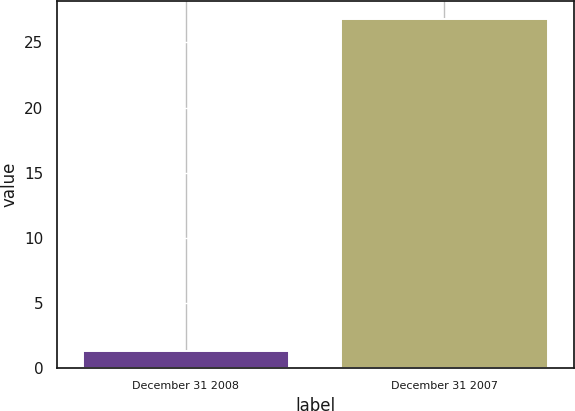Convert chart to OTSL. <chart><loc_0><loc_0><loc_500><loc_500><bar_chart><fcel>December 31 2008<fcel>December 31 2007<nl><fcel>1.3<fcel>26.8<nl></chart> 